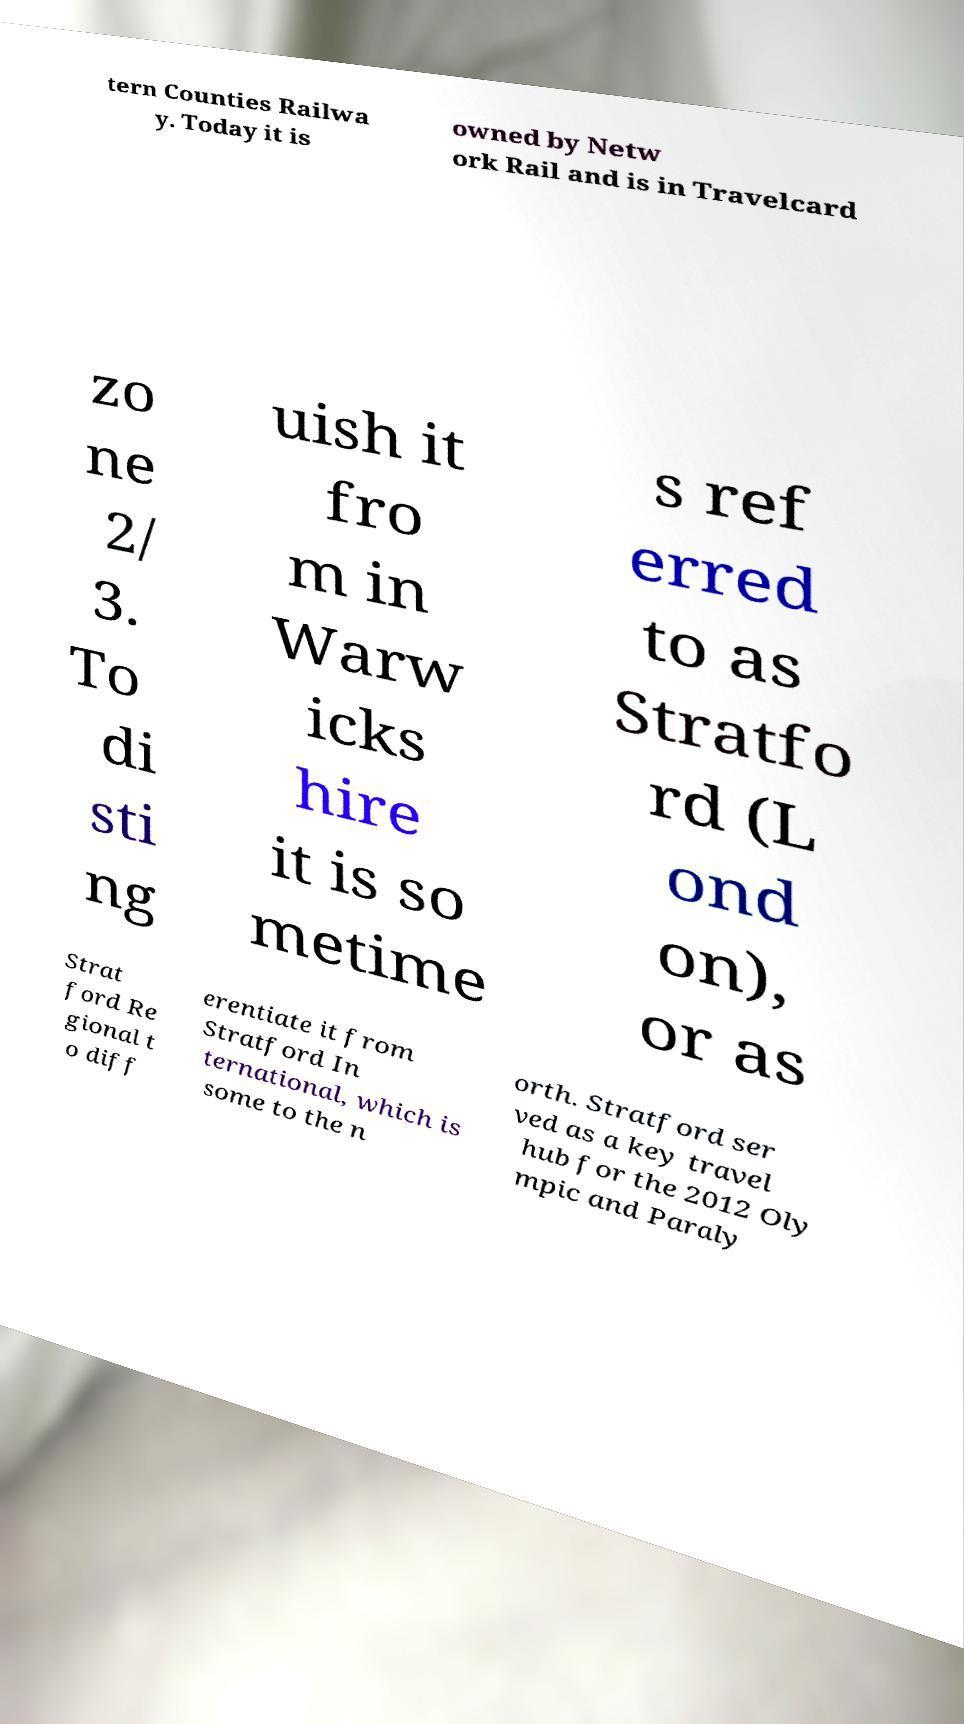Can you read and provide the text displayed in the image?This photo seems to have some interesting text. Can you extract and type it out for me? tern Counties Railwa y. Today it is owned by Netw ork Rail and is in Travelcard zo ne 2/ 3. To di sti ng uish it fro m in Warw icks hire it is so metime s ref erred to as Stratfo rd (L ond on), or as Strat ford Re gional t o diff erentiate it from Stratford In ternational, which is some to the n orth. Stratford ser ved as a key travel hub for the 2012 Oly mpic and Paraly 